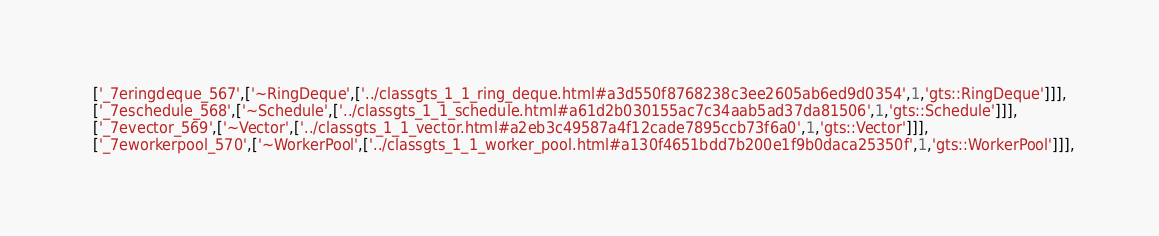Convert code to text. <code><loc_0><loc_0><loc_500><loc_500><_JavaScript_>  ['_7eringdeque_567',['~RingDeque',['../classgts_1_1_ring_deque.html#a3d550f8768238c3ee2605ab6ed9d0354',1,'gts::RingDeque']]],
  ['_7eschedule_568',['~Schedule',['../classgts_1_1_schedule.html#a61d2b030155ac7c34aab5ad37da81506',1,'gts::Schedule']]],
  ['_7evector_569',['~Vector',['../classgts_1_1_vector.html#a2eb3c49587a4f12cade7895ccb73f6a0',1,'gts::Vector']]],
  ['_7eworkerpool_570',['~WorkerPool',['../classgts_1_1_worker_pool.html#a130f4651bdd7b200e1f9b0daca25350f',1,'gts::WorkerPool']]],</code> 